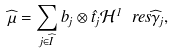Convert formula to latex. <formula><loc_0><loc_0><loc_500><loc_500>\widehat { \mu } = \sum _ { j \in \widehat { I } } b _ { j } \otimes \hat { t } _ { j } \mathcal { H } ^ { 1 } \ r e s \widehat { \gamma } _ { j } ,</formula> 